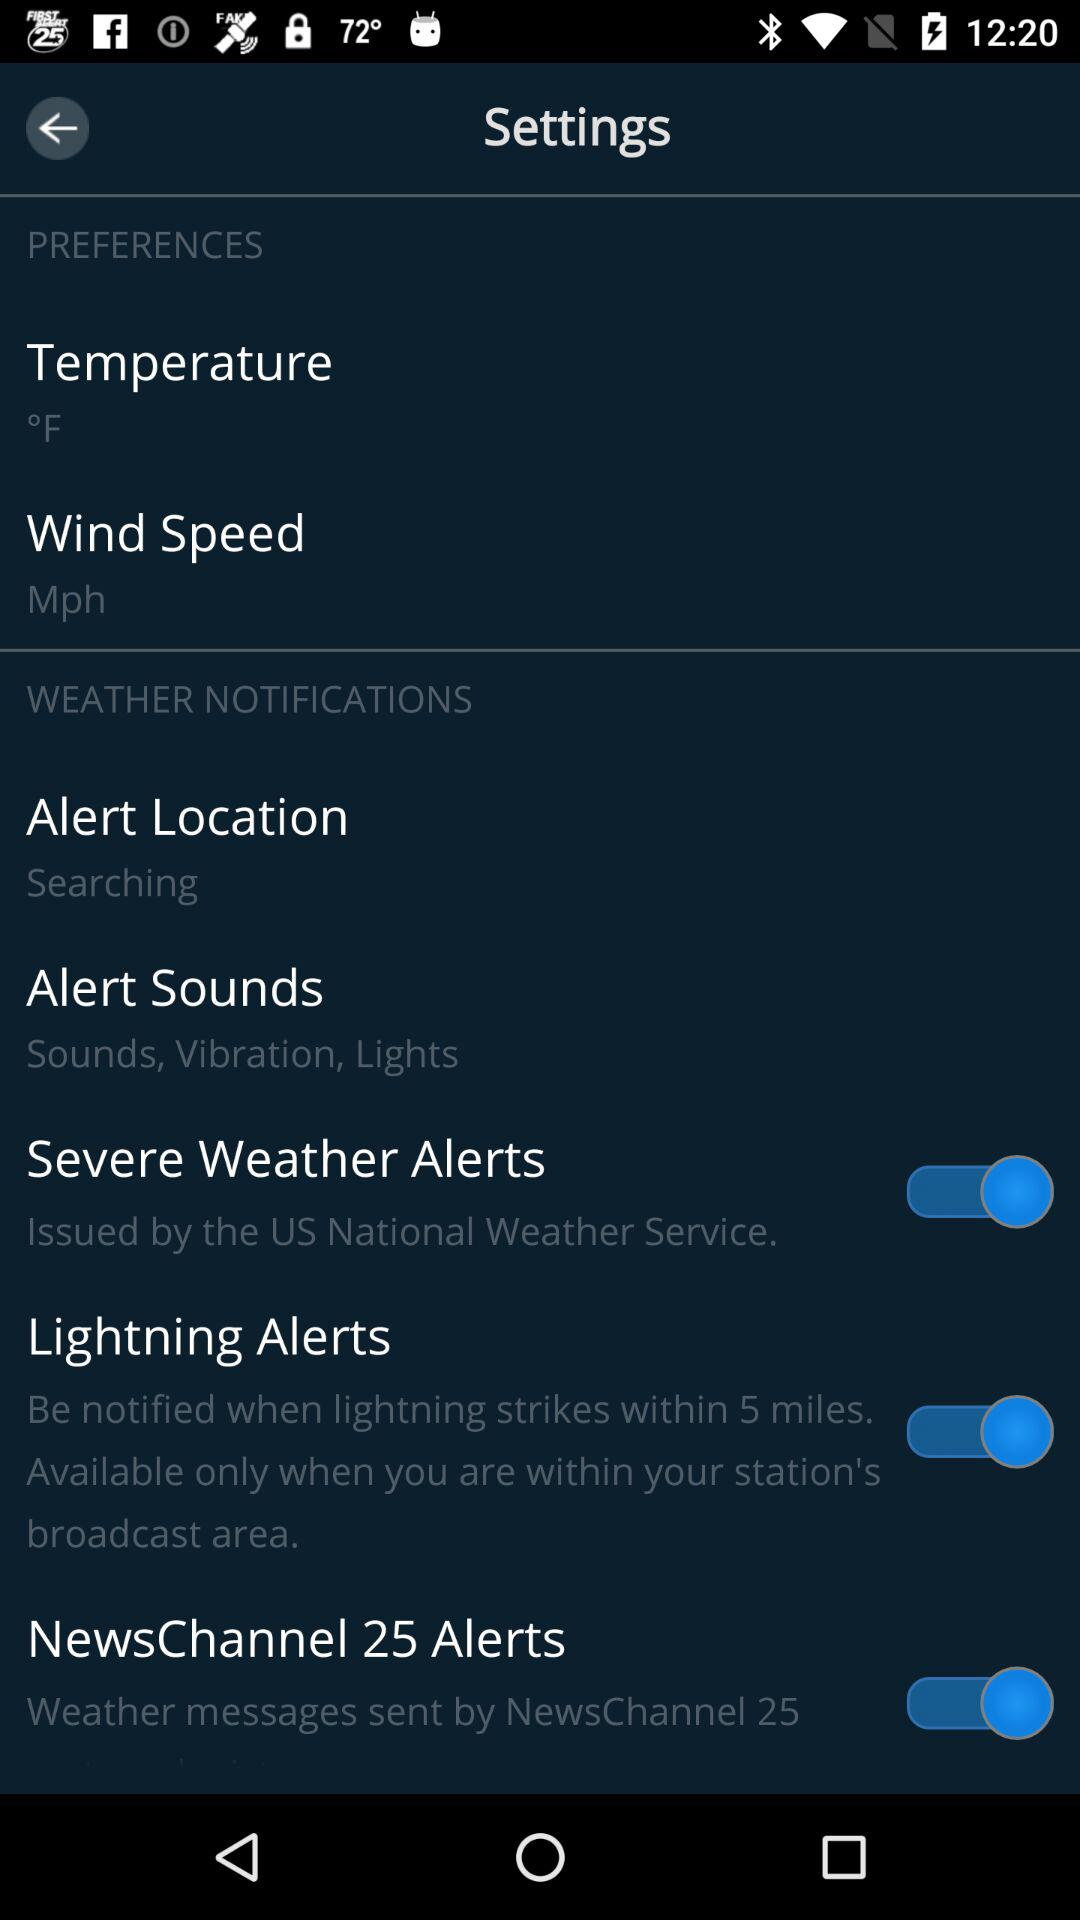How many items in the Weather Notifications section have a switch?
Answer the question using a single word or phrase. 3 